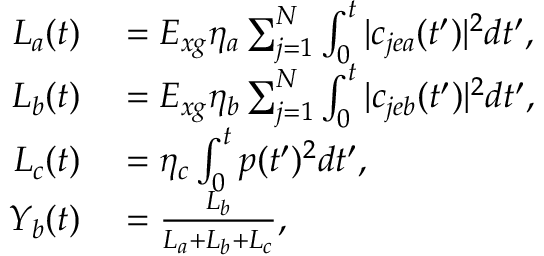<formula> <loc_0><loc_0><loc_500><loc_500>\begin{array} { r l } { L _ { a } ( t ) } & = E _ { x g } \eta _ { a } \sum _ { j = 1 } ^ { N } \int _ { 0 } ^ { t } | c _ { j e a } ( t ^ { \prime } ) | ^ { 2 } d t ^ { \prime } , } \\ { L _ { b } ( t ) } & = E _ { x g } \eta _ { b } \sum _ { j = 1 } ^ { N } \int _ { 0 } ^ { t } | c _ { j e b } ( t ^ { \prime } ) | ^ { 2 } d t ^ { \prime } , } \\ { L _ { c } ( t ) } & = \eta _ { c } \int _ { 0 } ^ { t } p ( t ^ { \prime } ) ^ { 2 } d t ^ { \prime } , } \\ { Y _ { b } ( t ) } & = \frac { L _ { b } } { L _ { a } + L _ { b } + L _ { c } } , } \end{array}</formula> 